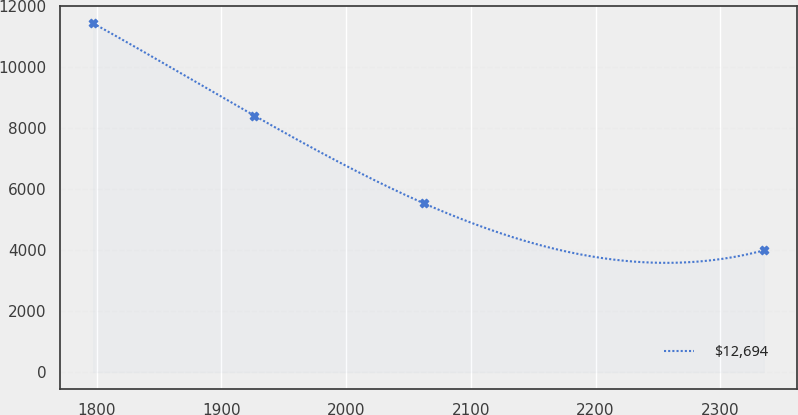Convert chart. <chart><loc_0><loc_0><loc_500><loc_500><line_chart><ecel><fcel>$12,694<nl><fcel>1797.2<fcel>11440.1<nl><fcel>1926.29<fcel>8414.4<nl><fcel>2062.35<fcel>5533.17<nl><fcel>2334.78<fcel>3989.4<nl></chart> 